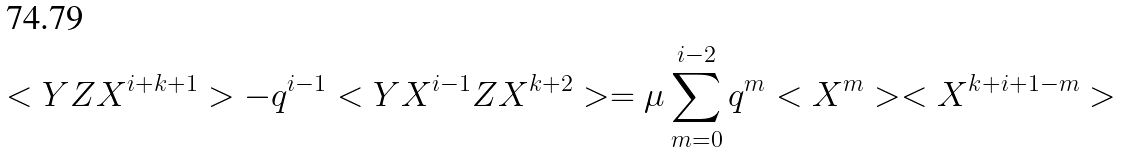<formula> <loc_0><loc_0><loc_500><loc_500>< Y Z X ^ { i + k + 1 } > - q ^ { i - 1 } < Y X ^ { i - 1 } Z X ^ { k + 2 } > = \mu \sum _ { m = 0 } ^ { i - 2 } q ^ { m } < X ^ { m } > < X ^ { k + i + 1 - m } ></formula> 